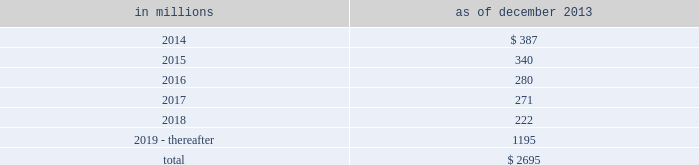Notes to consolidated financial statements sumitomo mitsui financial group , inc .
( smfg ) provides the firm with credit loss protection on certain approved loan commitments ( primarily investment-grade commercial lending commitments ) .
The notional amount of such loan commitments was $ 29.24 billion and $ 32.41 billion as of december 2013 and december 2012 , respectively .
The credit loss protection on loan commitments provided by smfg is generally limited to 95% ( 95 % ) of the first loss the firm realizes on such commitments , up to a maximum of approximately $ 950 million .
In addition , subject to the satisfaction of certain conditions , upon the firm 2019s request , smfg will provide protection for 70% ( 70 % ) of additional losses on such commitments , up to a maximum of $ 1.13 billion , of which $ 870 million and $ 300 million of protection had been provided as of december 2013 and december 2012 , respectively .
The firm also uses other financial instruments to mitigate credit risks related to certain commitments not covered by smfg .
These instruments primarily include credit default swaps that reference the same or similar underlying instrument or entity , or credit default swaps that reference a market index .
Warehouse financing .
The firm provides financing to clients who warehouse financial assets .
These arrangements are secured by the warehoused assets , primarily consisting of corporate loans and commercial mortgage loans .
Contingent and forward starting resale and securities borrowing agreements/forward starting repurchase and secured lending agreements the firm enters into resale and securities borrowing agreements and repurchase and secured lending agreements that settle at a future date , generally within three business days .
The firm also enters into commitments to provide contingent financing to its clients and counterparties through resale agreements .
The firm 2019s funding of these commitments depends on the satisfaction of all contractual conditions to the resale agreement and these commitments can expire unused .
Investment commitments the firm 2019s investment commitments consist of commitments to invest in private equity , real estate and other assets directly and through funds that the firm raises and manages .
These commitments include $ 659 million and $ 872 million as of december 2013 and december 2012 , respectively , related to real estate private investments and $ 6.46 billion and $ 6.47 billion as of december 2013 and december 2012 , respectively , related to corporate and other private investments .
Of these amounts , $ 5.48 billion and $ 6.21 billion as of december 2013 and december 2012 , respectively , relate to commitments to invest in funds managed by the firm .
If these commitments are called , they would be funded at market value on the date of investment .
Leases the firm has contractual obligations under long-term noncancelable lease agreements , principally for office space , expiring on various dates through 2069 .
Certain agreements are subject to periodic escalation provisions for increases in real estate taxes and other charges .
The table below presents future minimum rental payments , net of minimum sublease rentals .
In millions december 2013 .
Rent charged to operating expense was $ 324 million for 2013 , $ 374 million for 2012 and $ 475 million for 2011 .
Operating leases include office space held in excess of current requirements .
Rent expense relating to space held for growth is included in 201coccupancy . 201d the firm records a liability , based on the fair value of the remaining lease rentals reduced by any potential or existing sublease rentals , for leases where the firm has ceased using the space and management has concluded that the firm will not derive any future economic benefits .
Costs to terminate a lease before the end of its term are recognized and measured at fair value on termination .
Contingencies legal proceedings .
See note 27 for information about legal proceedings , including certain mortgage-related matters .
Certain mortgage-related contingencies .
There are multiple areas of focus by regulators , governmental agencies and others within the mortgage market that may impact originators , issuers , servicers and investors .
There remains significant uncertainty surrounding the nature and extent of any potential exposure for participants in this market .
182 goldman sachs 2013 annual report .
In billions for the years december 2013 and december 2012 , what was total commitments to invest in funds managed by the firm? 
Computations: (5.48 + 6.21)
Answer: 11.69. 